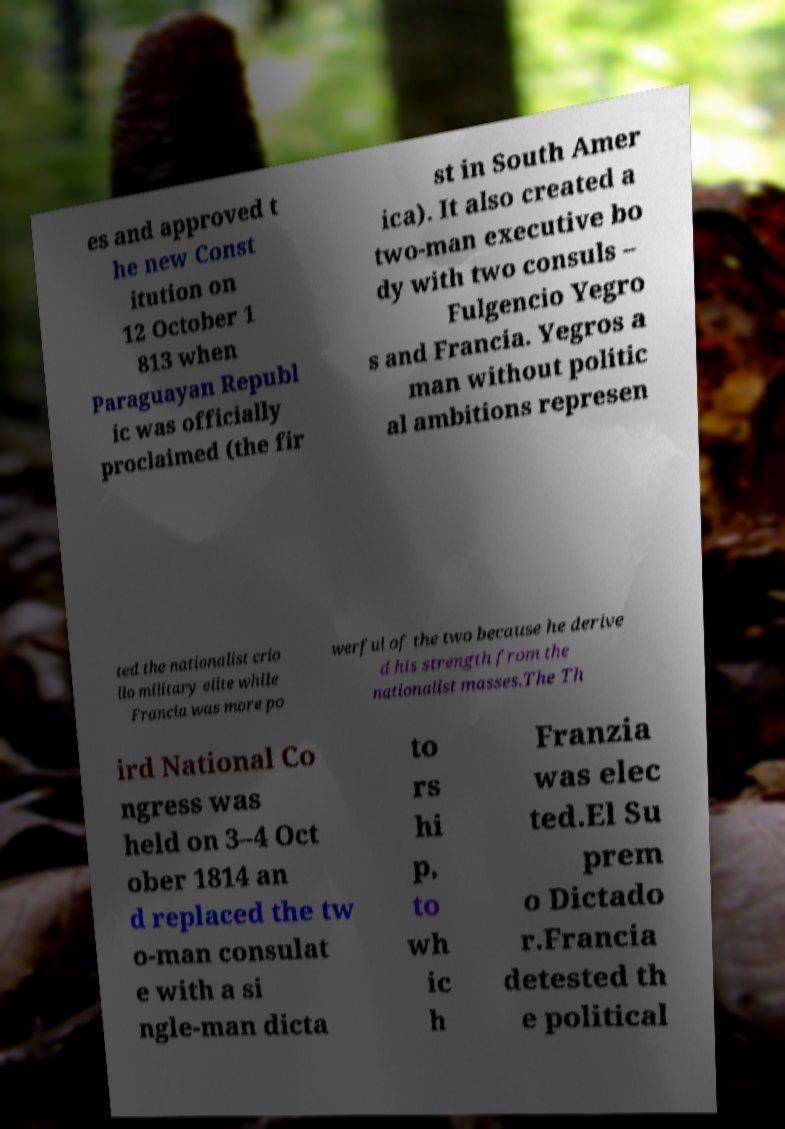There's text embedded in this image that I need extracted. Can you transcribe it verbatim? es and approved t he new Const itution on 12 October 1 813 when Paraguayan Republ ic was officially proclaimed (the fir st in South Amer ica). It also created a two-man executive bo dy with two consuls – Fulgencio Yegro s and Francia. Yegros a man without politic al ambitions represen ted the nationalist crio llo military elite while Francia was more po werful of the two because he derive d his strength from the nationalist masses.The Th ird National Co ngress was held on 3–4 Oct ober 1814 an d replaced the tw o-man consulat e with a si ngle-man dicta to rs hi p, to wh ic h Franzia was elec ted.El Su prem o Dictado r.Francia detested th e political 